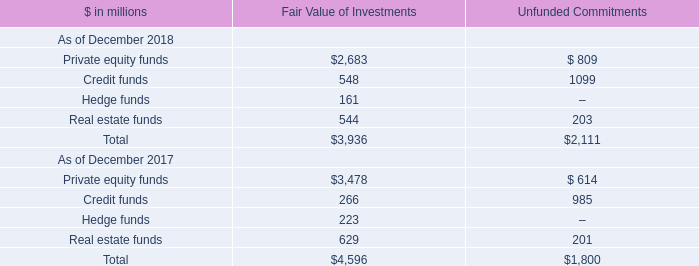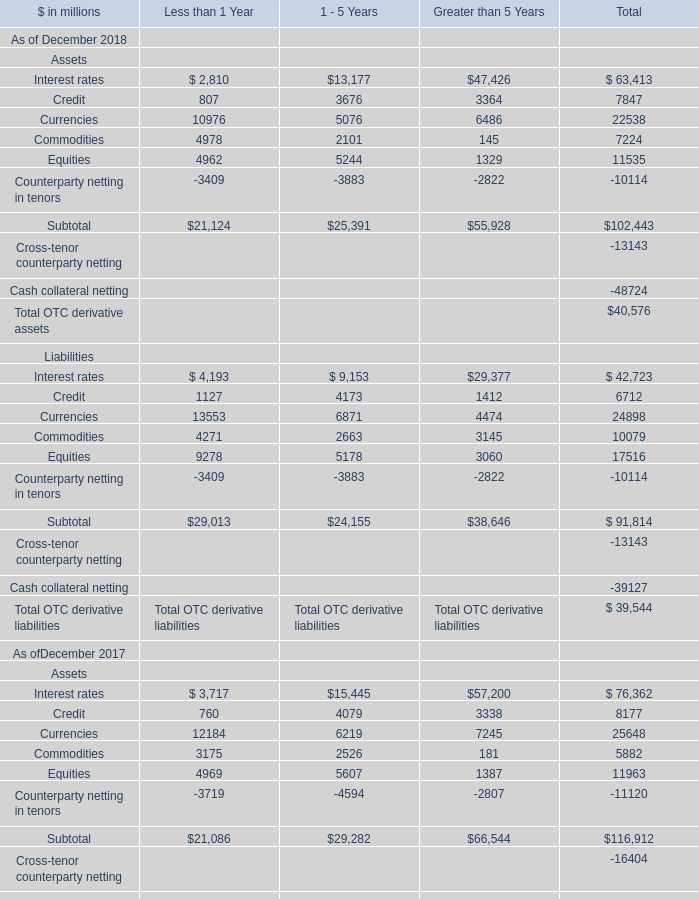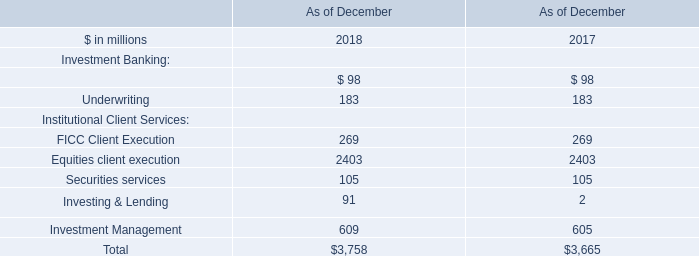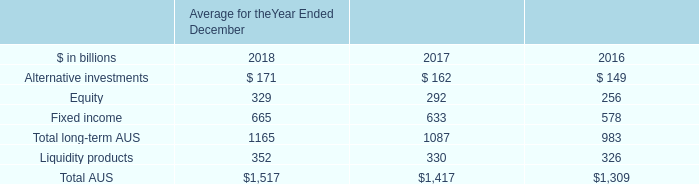Which year has the greatest proportion of Credit for assets in total? 
Computations: ((7847 / 102443) - (8177 / 116912))
Answer: 0.00666. 